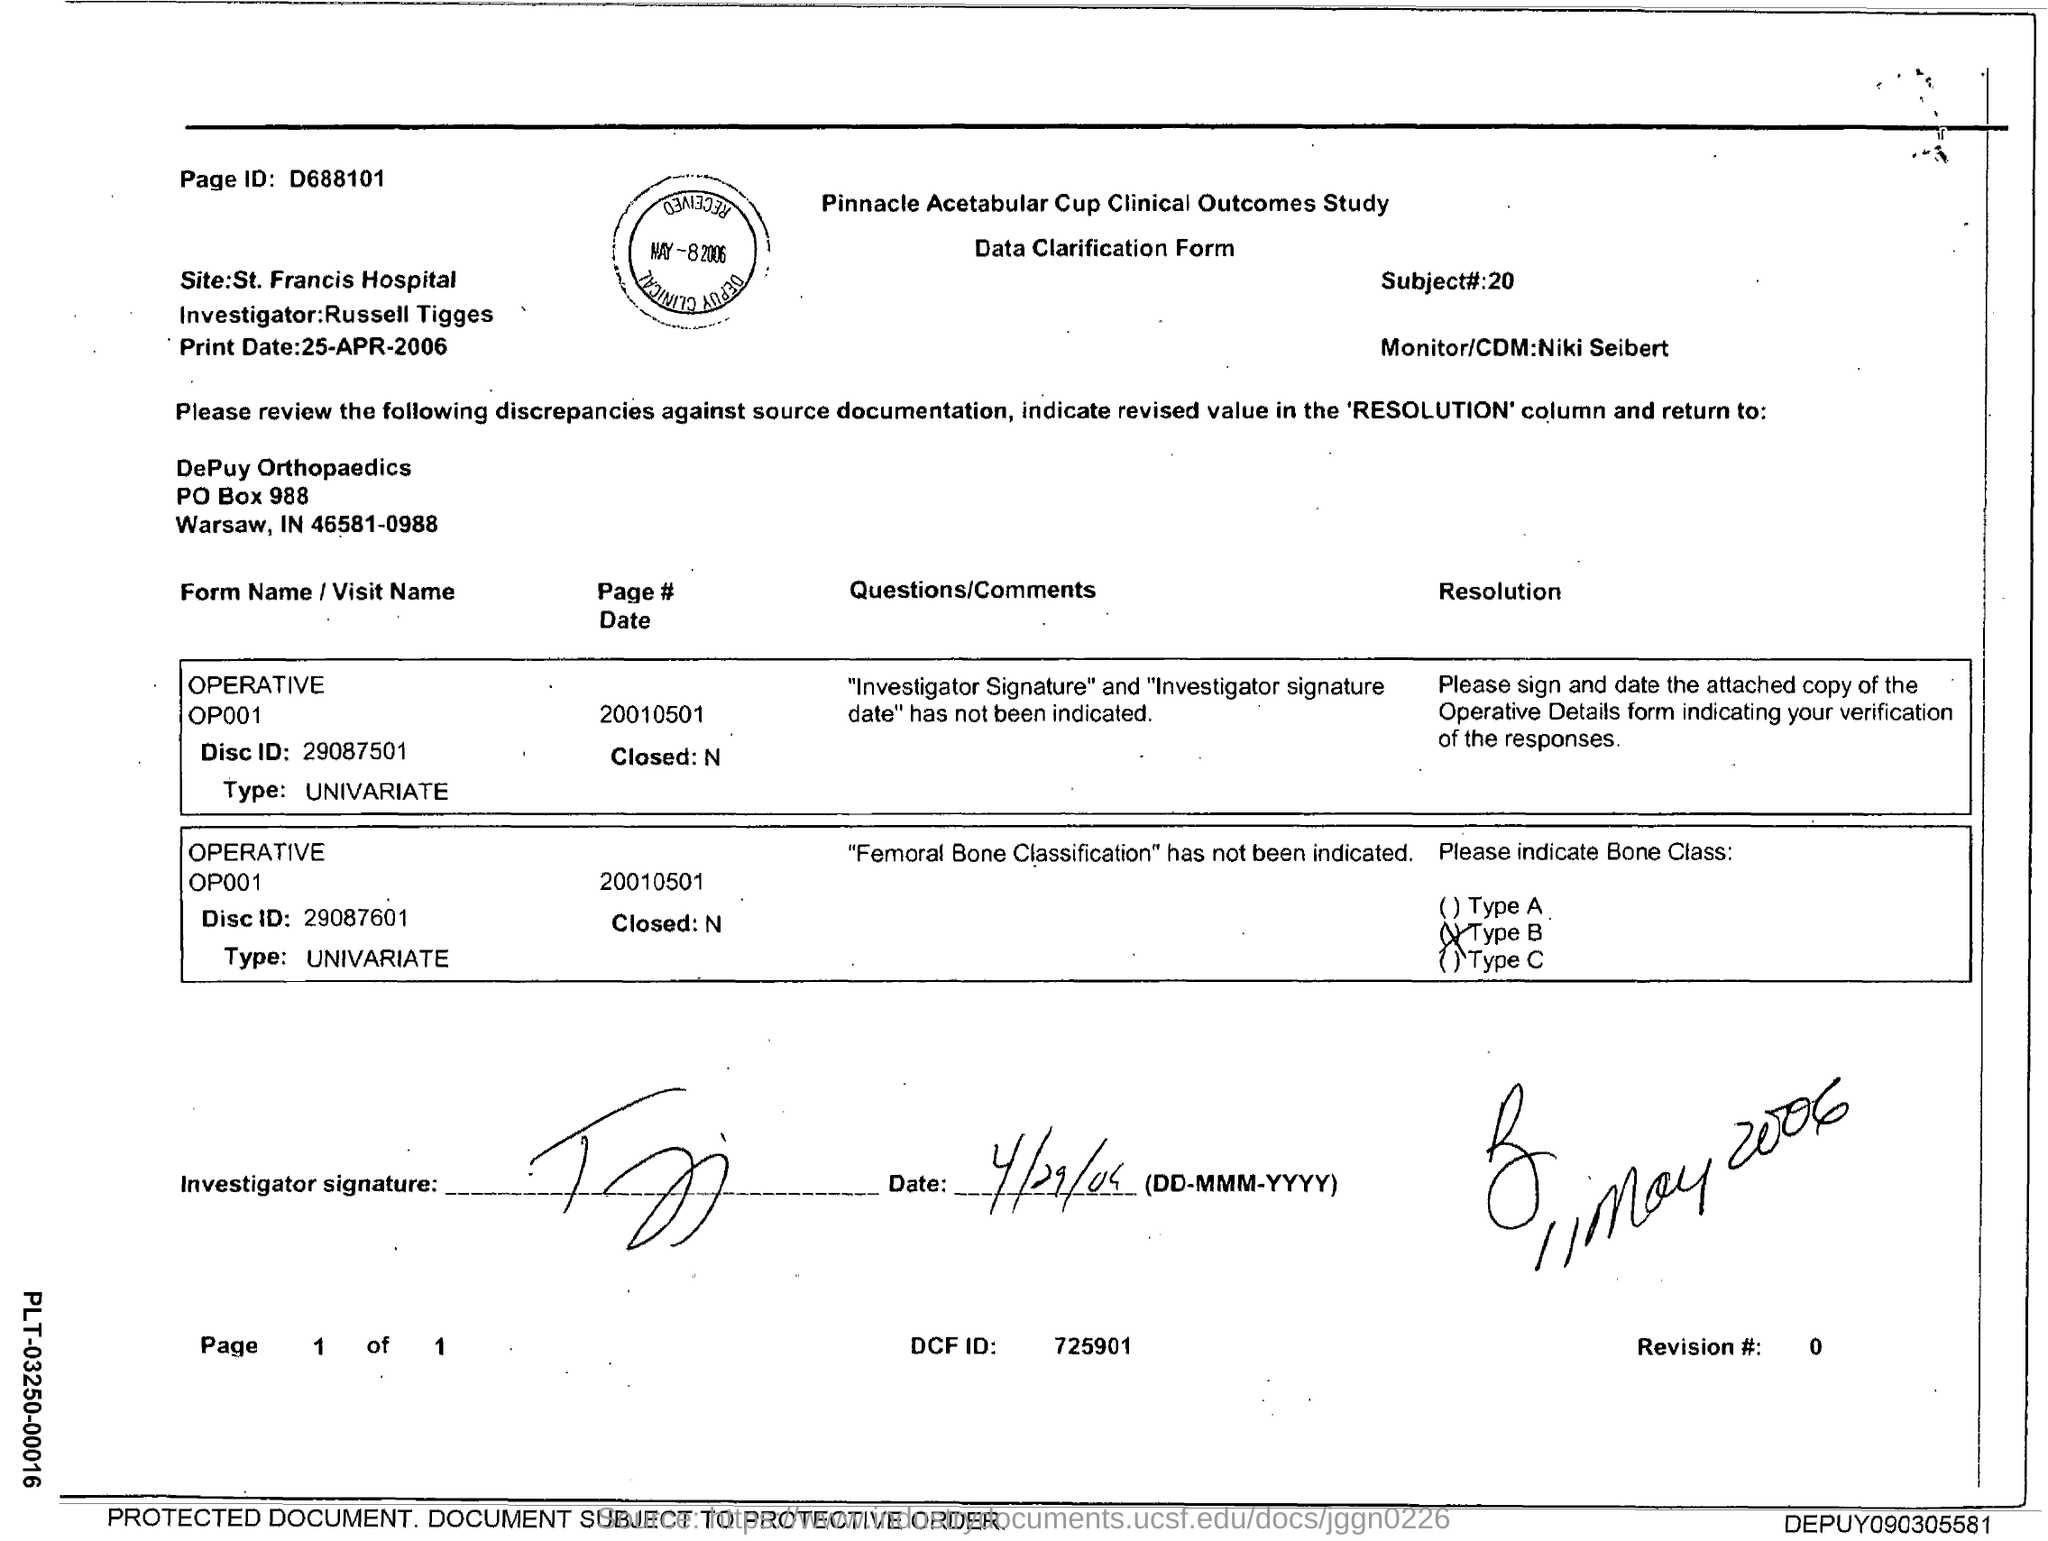What is the page ID mention on the top left?
Your answer should be compact. D688101. Which bone class was indicated?
Ensure brevity in your answer.  Type b. 